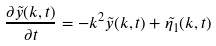<formula> <loc_0><loc_0><loc_500><loc_500>\frac { \partial { \tilde { y } ( k , t ) } } { \partial { t } } = - k ^ { 2 } \tilde { y } ( k , t ) + \tilde { \eta _ { 1 } } ( k , t )</formula> 